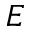<formula> <loc_0><loc_0><loc_500><loc_500>E</formula> 